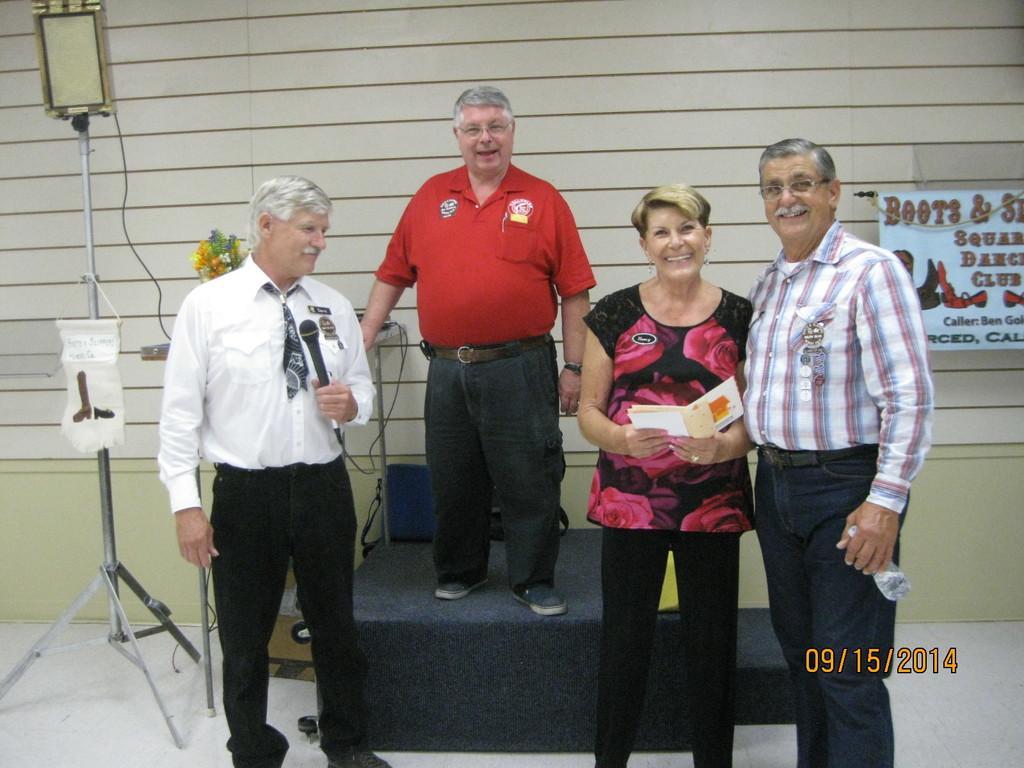Could you give a brief overview of what you see in this image? There are total four people in the image and one of the person is standing on the dais and the first person is holding mic in his hand,behind that person there is a stand and in the background there is a wall and some poster is attached to the wall. 